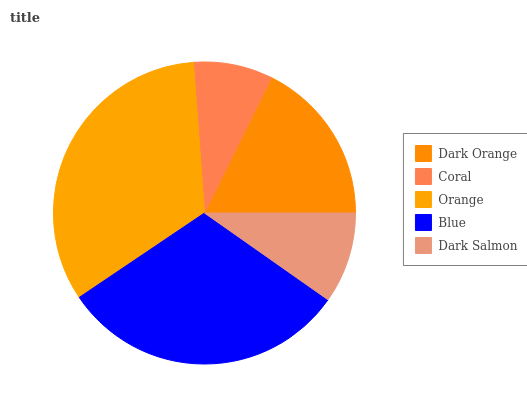Is Coral the minimum?
Answer yes or no. Yes. Is Orange the maximum?
Answer yes or no. Yes. Is Orange the minimum?
Answer yes or no. No. Is Coral the maximum?
Answer yes or no. No. Is Orange greater than Coral?
Answer yes or no. Yes. Is Coral less than Orange?
Answer yes or no. Yes. Is Coral greater than Orange?
Answer yes or no. No. Is Orange less than Coral?
Answer yes or no. No. Is Dark Orange the high median?
Answer yes or no. Yes. Is Dark Orange the low median?
Answer yes or no. Yes. Is Blue the high median?
Answer yes or no. No. Is Dark Salmon the low median?
Answer yes or no. No. 